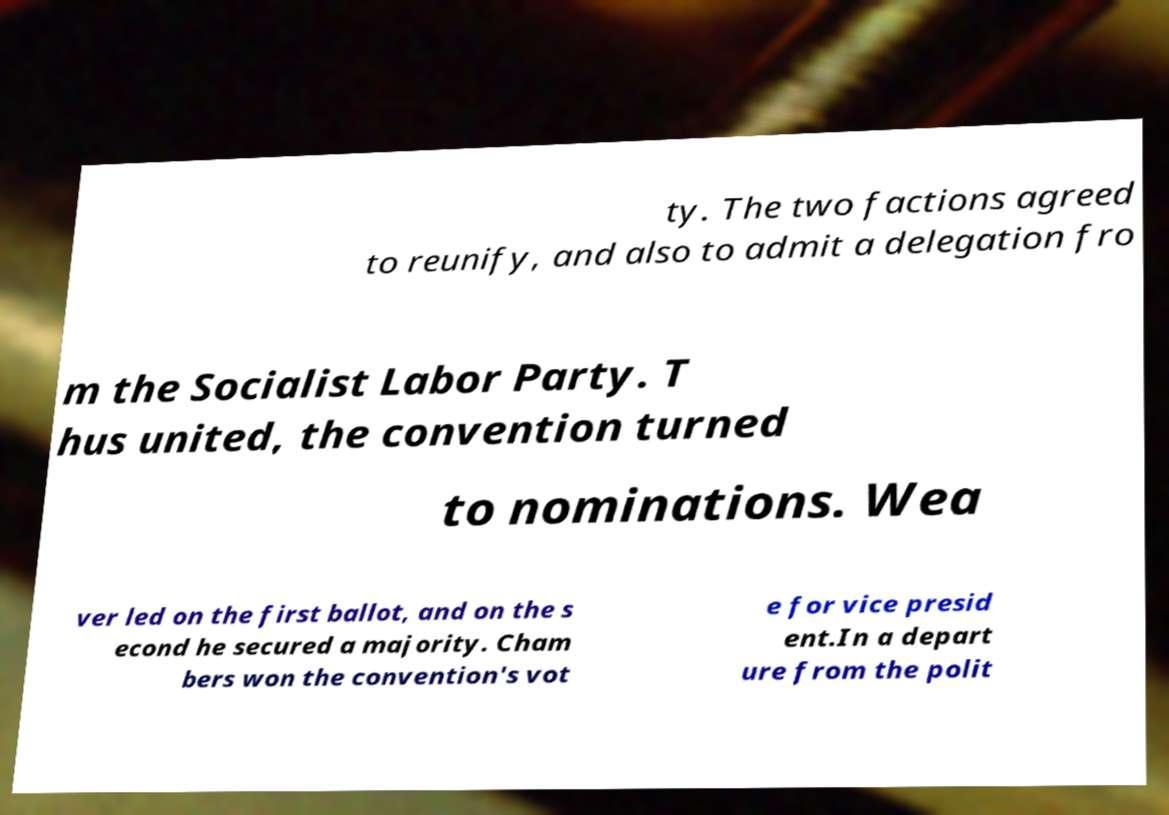What messages or text are displayed in this image? I need them in a readable, typed format. ty. The two factions agreed to reunify, and also to admit a delegation fro m the Socialist Labor Party. T hus united, the convention turned to nominations. Wea ver led on the first ballot, and on the s econd he secured a majority. Cham bers won the convention's vot e for vice presid ent.In a depart ure from the polit 